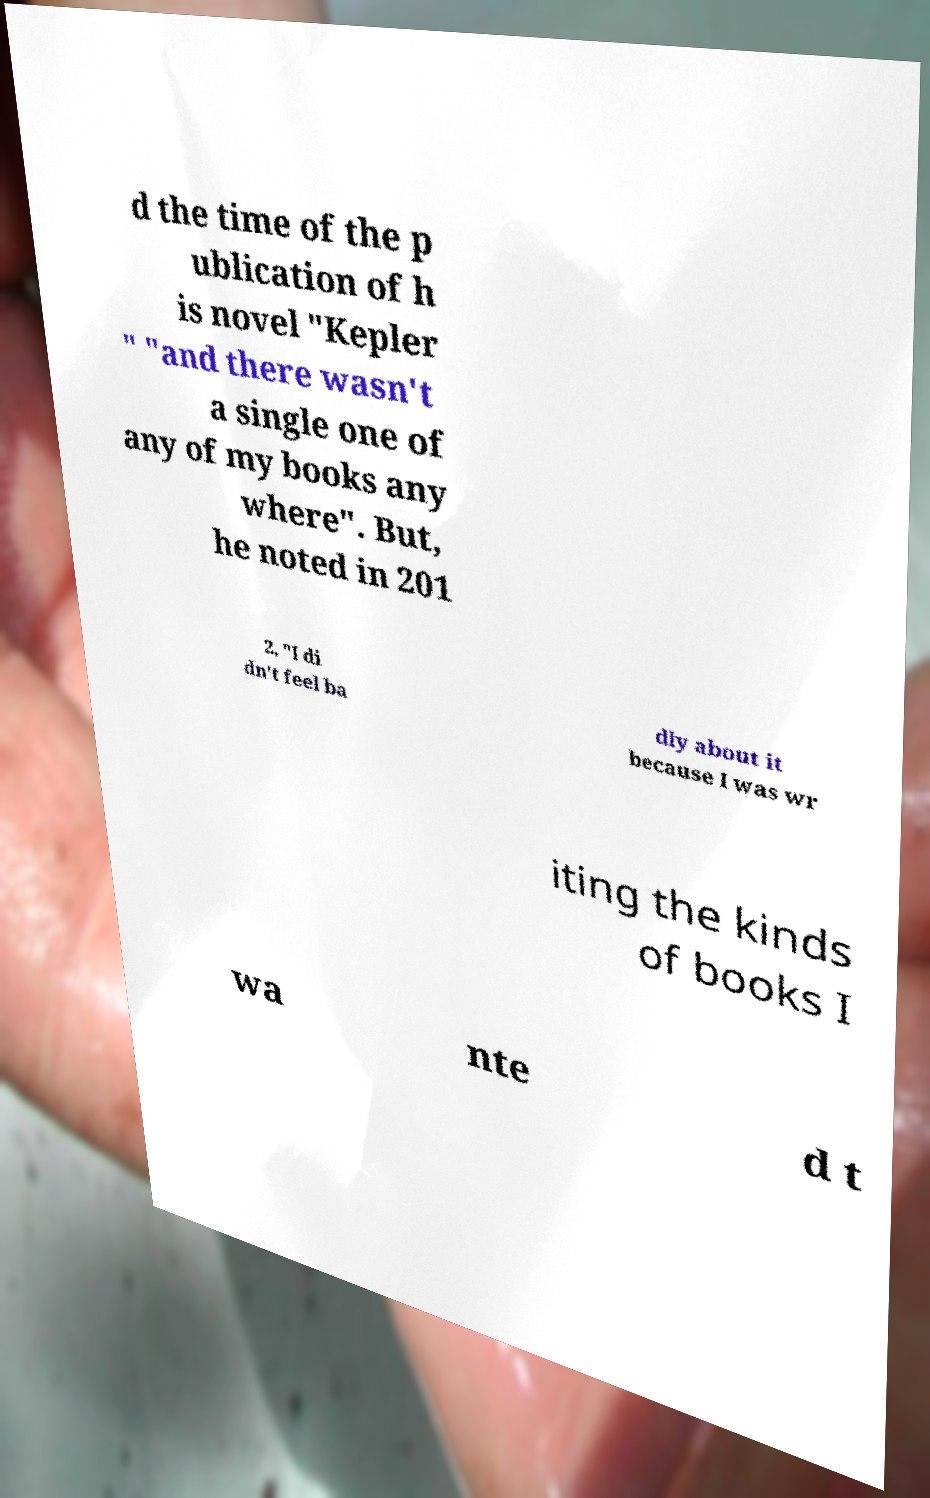Please read and relay the text visible in this image. What does it say? d the time of the p ublication of h is novel "Kepler " "and there wasn't a single one of any of my books any where". But, he noted in 201 2, "I di dn't feel ba dly about it because I was wr iting the kinds of books I wa nte d t 